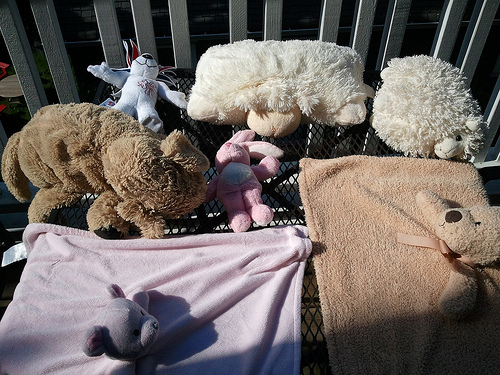<image>
Is the fence to the right of the toy? No. The fence is not to the right of the toy. The horizontal positioning shows a different relationship. 